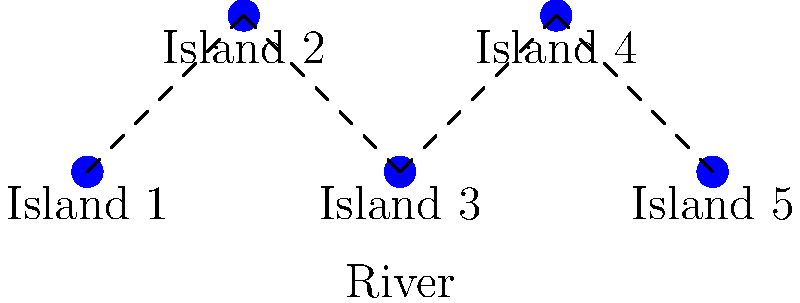As part of a community development project, we need to connect five islands in our local river system with bridges. What is the minimum number of bridges required to ensure all islands are accessible from one another? To find the minimum number of bridges needed, we can use the concept of a minimum spanning tree in graph theory. Here's the step-by-step explanation:

1. We have 5 islands, which can be represented as vertices in a graph.
2. The bridges between islands are the edges of the graph.
3. To connect all islands with the minimum number of bridges, we need to find a tree that spans all vertices (islands) with the minimum number of edges (bridges).
4. In any tree, the number of edges is always one less than the number of vertices.
5. Therefore, the minimum number of bridges needed is:
   $$\text{Number of bridges} = \text{Number of islands} - 1$$
   $$\text{Number of bridges} = 5 - 1 = 4$$

This configuration ensures that all islands are connected, and removing any bridge would disconnect the system.
Answer: 4 bridges 